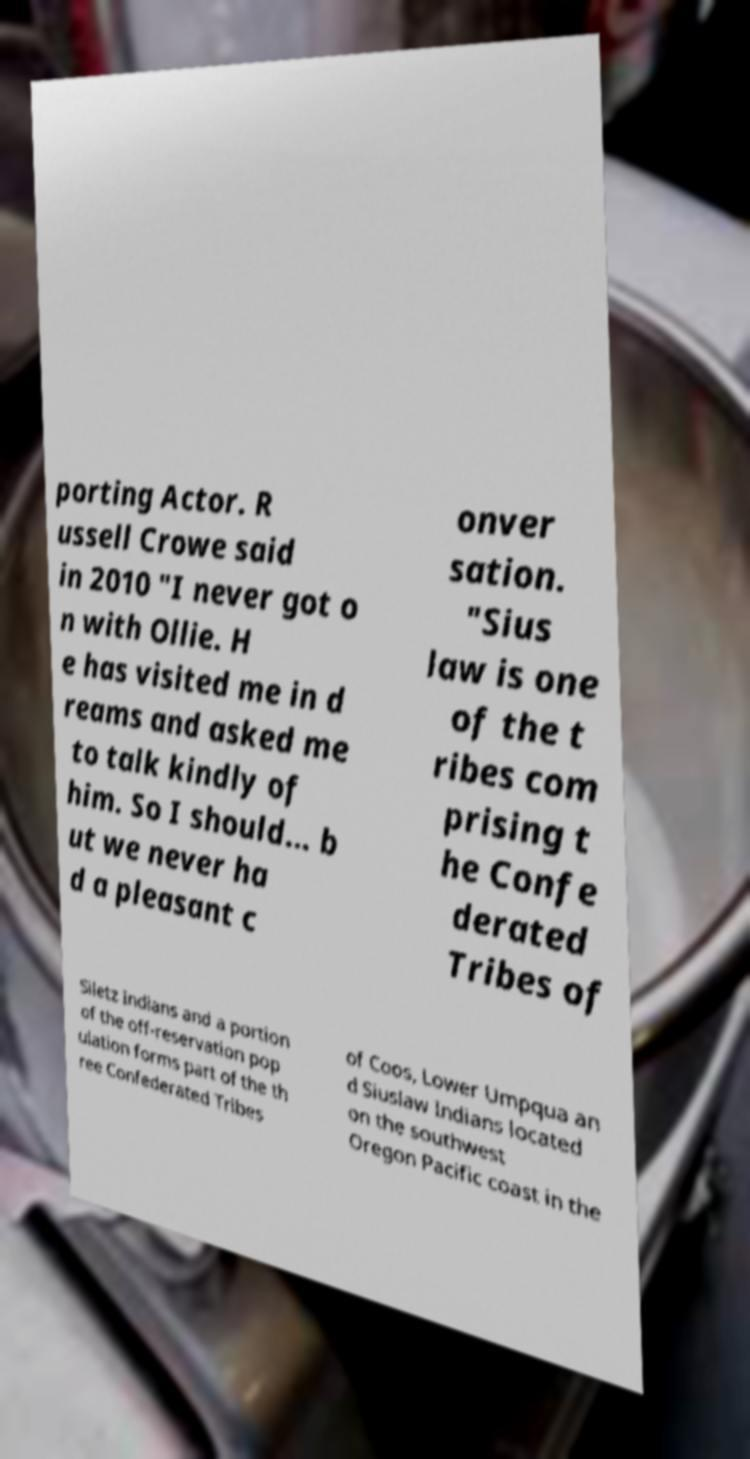There's text embedded in this image that I need extracted. Can you transcribe it verbatim? porting Actor. R ussell Crowe said in 2010 "I never got o n with Ollie. H e has visited me in d reams and asked me to talk kindly of him. So I should... b ut we never ha d a pleasant c onver sation. "Sius law is one of the t ribes com prising t he Confe derated Tribes of Siletz Indians and a portion of the off-reservation pop ulation forms part of the th ree Confederated Tribes of Coos, Lower Umpqua an d Siuslaw Indians located on the southwest Oregon Pacific coast in the 